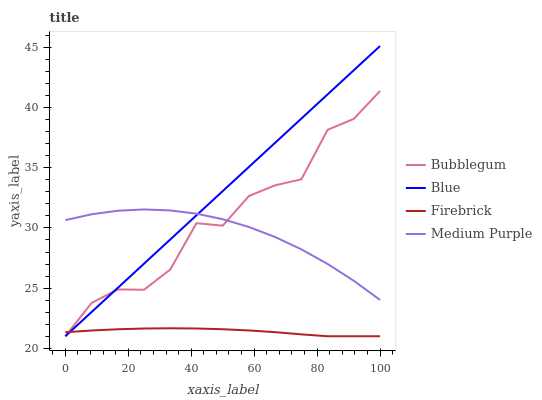Does Firebrick have the minimum area under the curve?
Answer yes or no. Yes. Does Blue have the maximum area under the curve?
Answer yes or no. Yes. Does Medium Purple have the minimum area under the curve?
Answer yes or no. No. Does Medium Purple have the maximum area under the curve?
Answer yes or no. No. Is Blue the smoothest?
Answer yes or no. Yes. Is Bubblegum the roughest?
Answer yes or no. Yes. Is Medium Purple the smoothest?
Answer yes or no. No. Is Medium Purple the roughest?
Answer yes or no. No. Does Blue have the lowest value?
Answer yes or no. Yes. Does Medium Purple have the lowest value?
Answer yes or no. No. Does Blue have the highest value?
Answer yes or no. Yes. Does Medium Purple have the highest value?
Answer yes or no. No. Is Firebrick less than Medium Purple?
Answer yes or no. Yes. Is Medium Purple greater than Firebrick?
Answer yes or no. Yes. Does Bubblegum intersect Firebrick?
Answer yes or no. Yes. Is Bubblegum less than Firebrick?
Answer yes or no. No. Is Bubblegum greater than Firebrick?
Answer yes or no. No. Does Firebrick intersect Medium Purple?
Answer yes or no. No. 